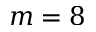<formula> <loc_0><loc_0><loc_500><loc_500>m = 8</formula> 